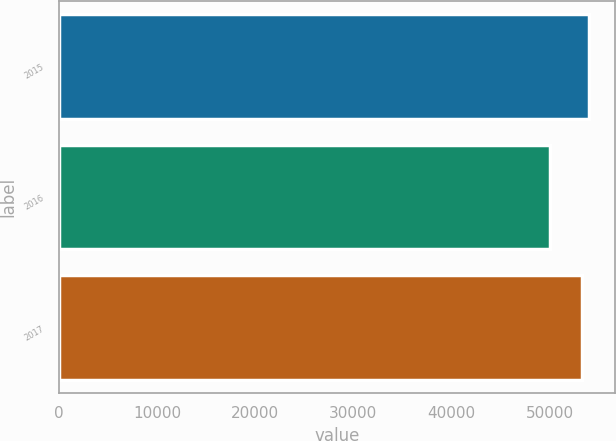<chart> <loc_0><loc_0><loc_500><loc_500><bar_chart><fcel>2015<fcel>2016<fcel>2017<nl><fcel>54006<fcel>50006<fcel>53339<nl></chart> 